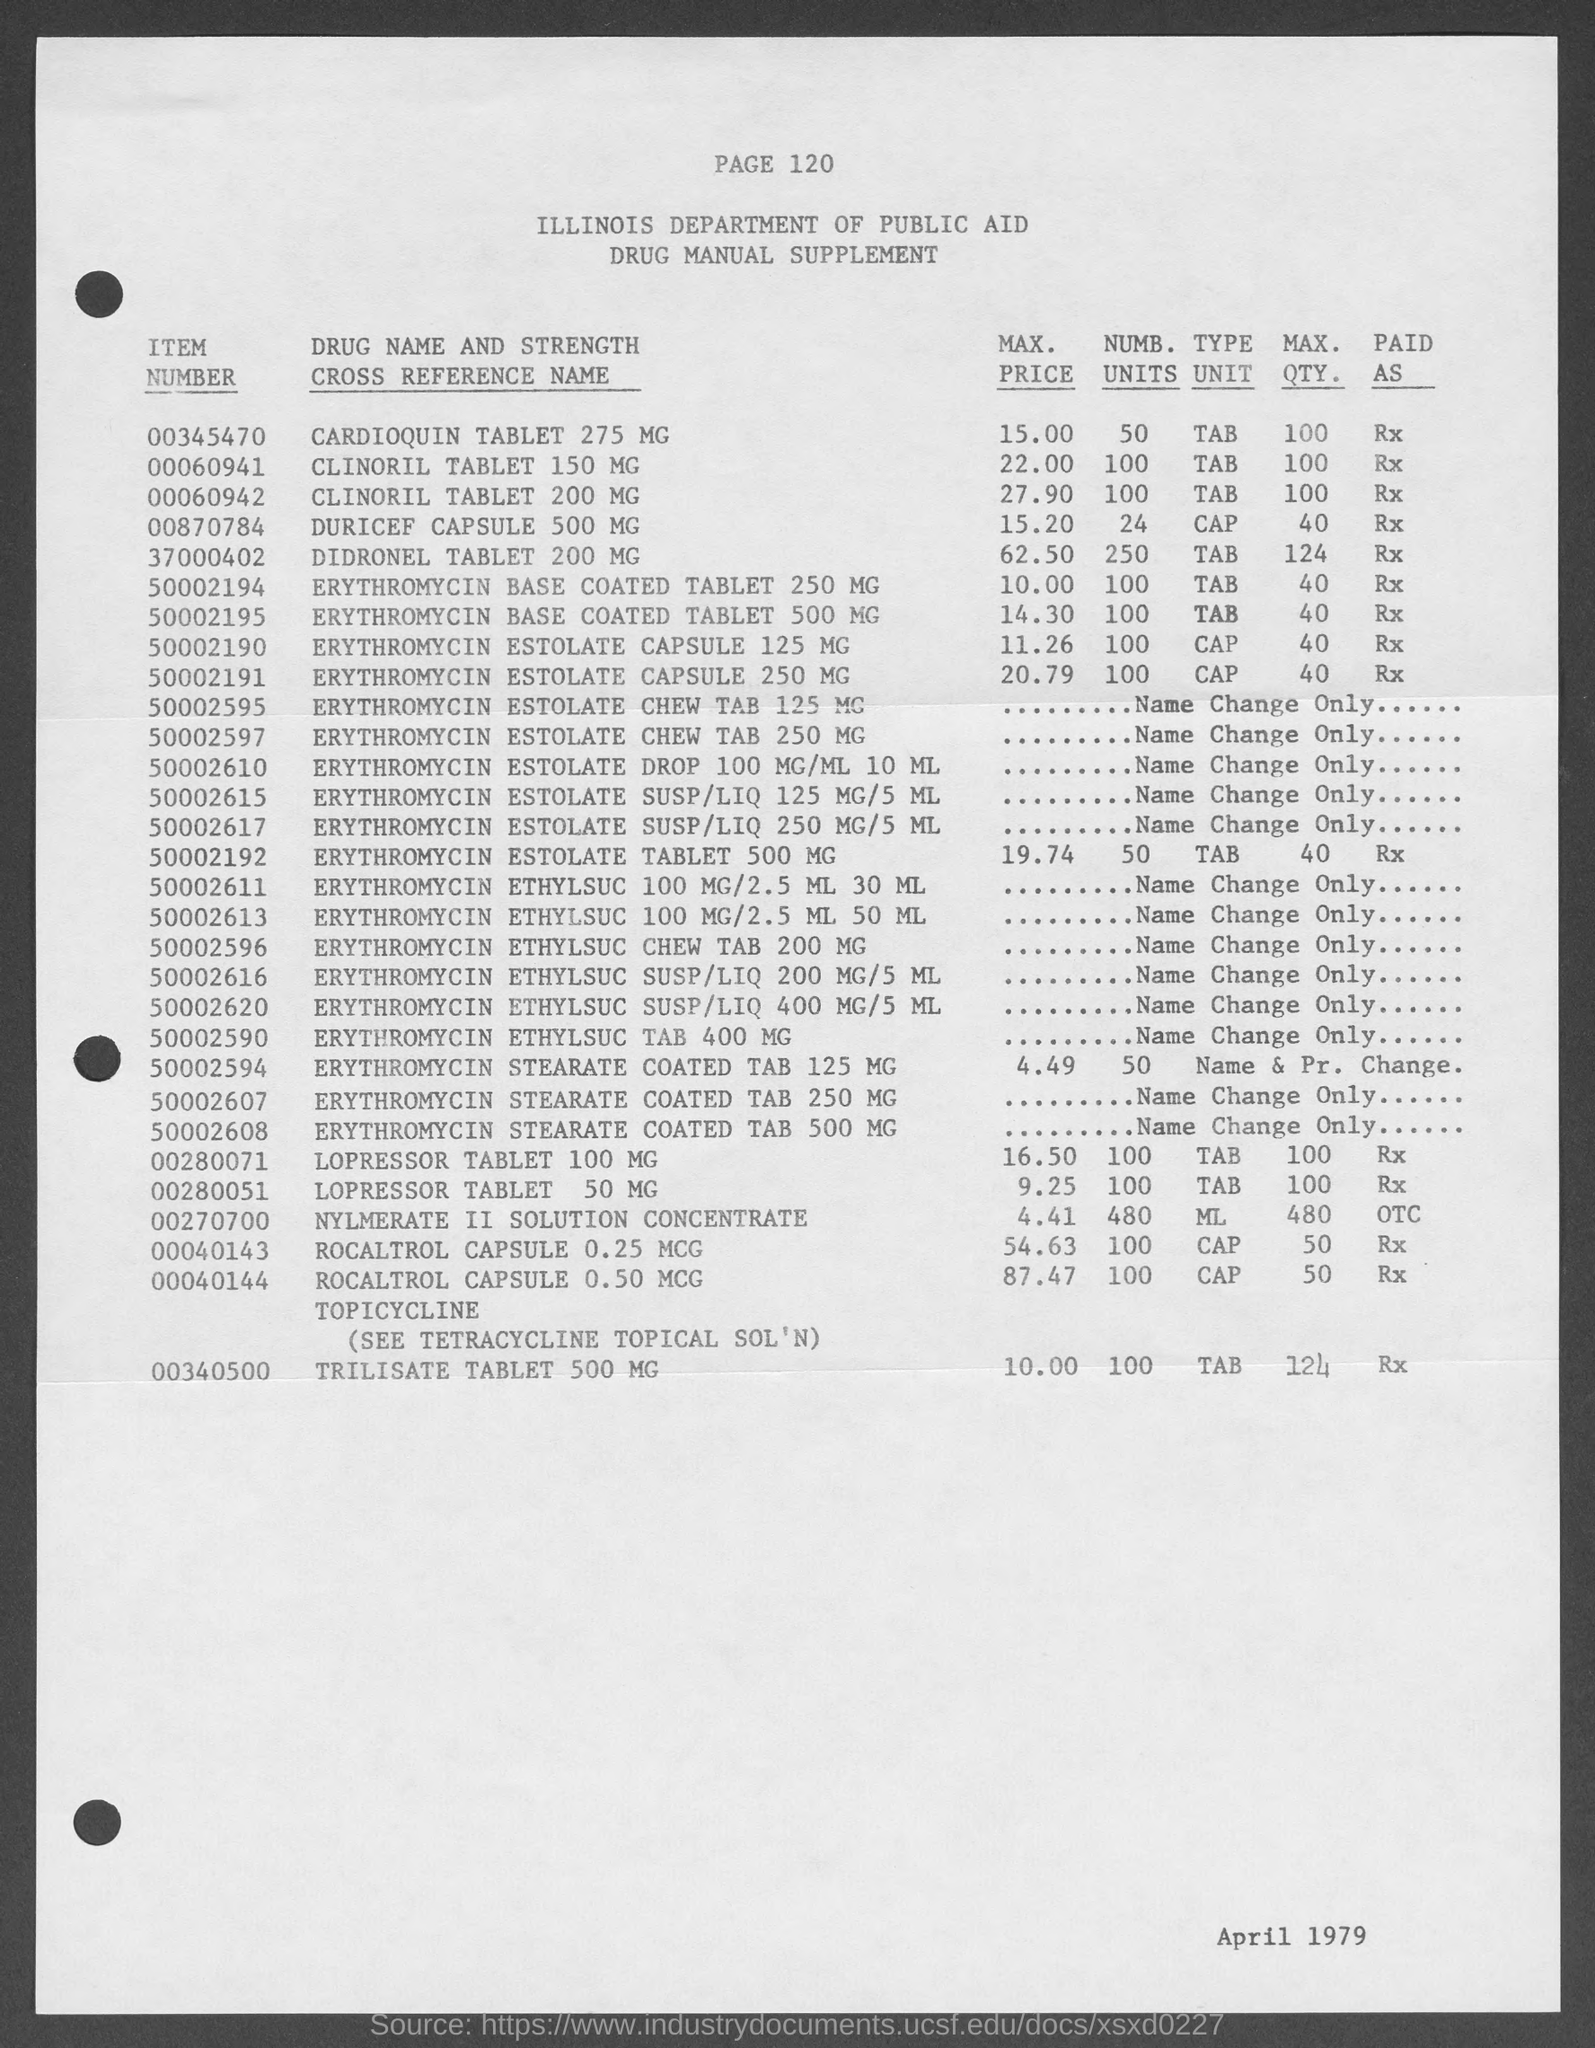Identify some key points in this picture. The maximum price of CLINORIL Tablet 150MG according to the document is 22.00. The maximum quantity of TRILISATE tablet 500mg according to the document is 124. The item number of DIDRONEL Tablet 200MG as mentioned in the document is 37000402. The item number of CLINORIL tablet 200MG as mentioned in the document is 00060942. The document states that the maximum quantity of Duricef Capsule 500MG is 40. 